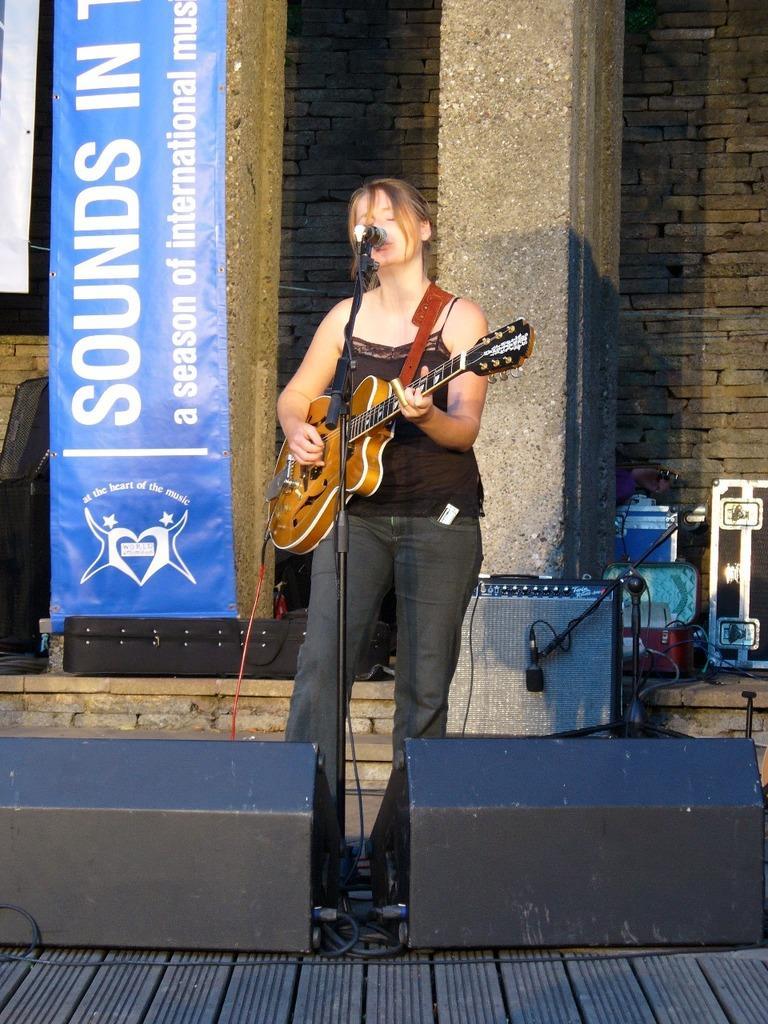Describe this image in one or two sentences. This is the image where a women is standing by holding a guitar in her hands and singing in the mic. These are the speakers. In the background there is a banner or poster. This is the building. This is the brick wall. 